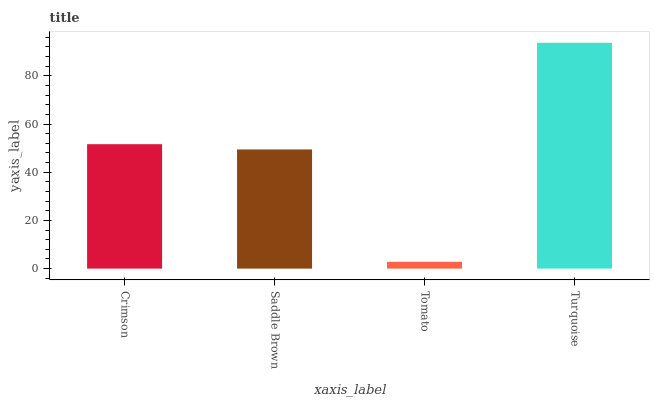Is Tomato the minimum?
Answer yes or no. Yes. Is Turquoise the maximum?
Answer yes or no. Yes. Is Saddle Brown the minimum?
Answer yes or no. No. Is Saddle Brown the maximum?
Answer yes or no. No. Is Crimson greater than Saddle Brown?
Answer yes or no. Yes. Is Saddle Brown less than Crimson?
Answer yes or no. Yes. Is Saddle Brown greater than Crimson?
Answer yes or no. No. Is Crimson less than Saddle Brown?
Answer yes or no. No. Is Crimson the high median?
Answer yes or no. Yes. Is Saddle Brown the low median?
Answer yes or no. Yes. Is Tomato the high median?
Answer yes or no. No. Is Turquoise the low median?
Answer yes or no. No. 